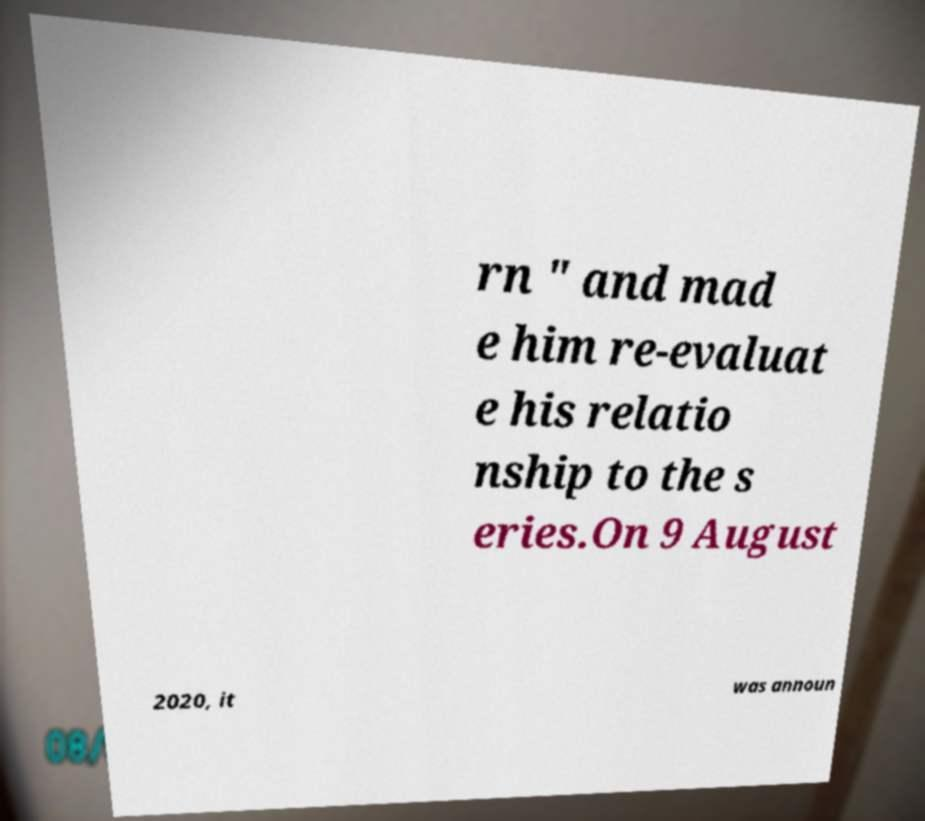What messages or text are displayed in this image? I need them in a readable, typed format. rn " and mad e him re-evaluat e his relatio nship to the s eries.On 9 August 2020, it was announ 